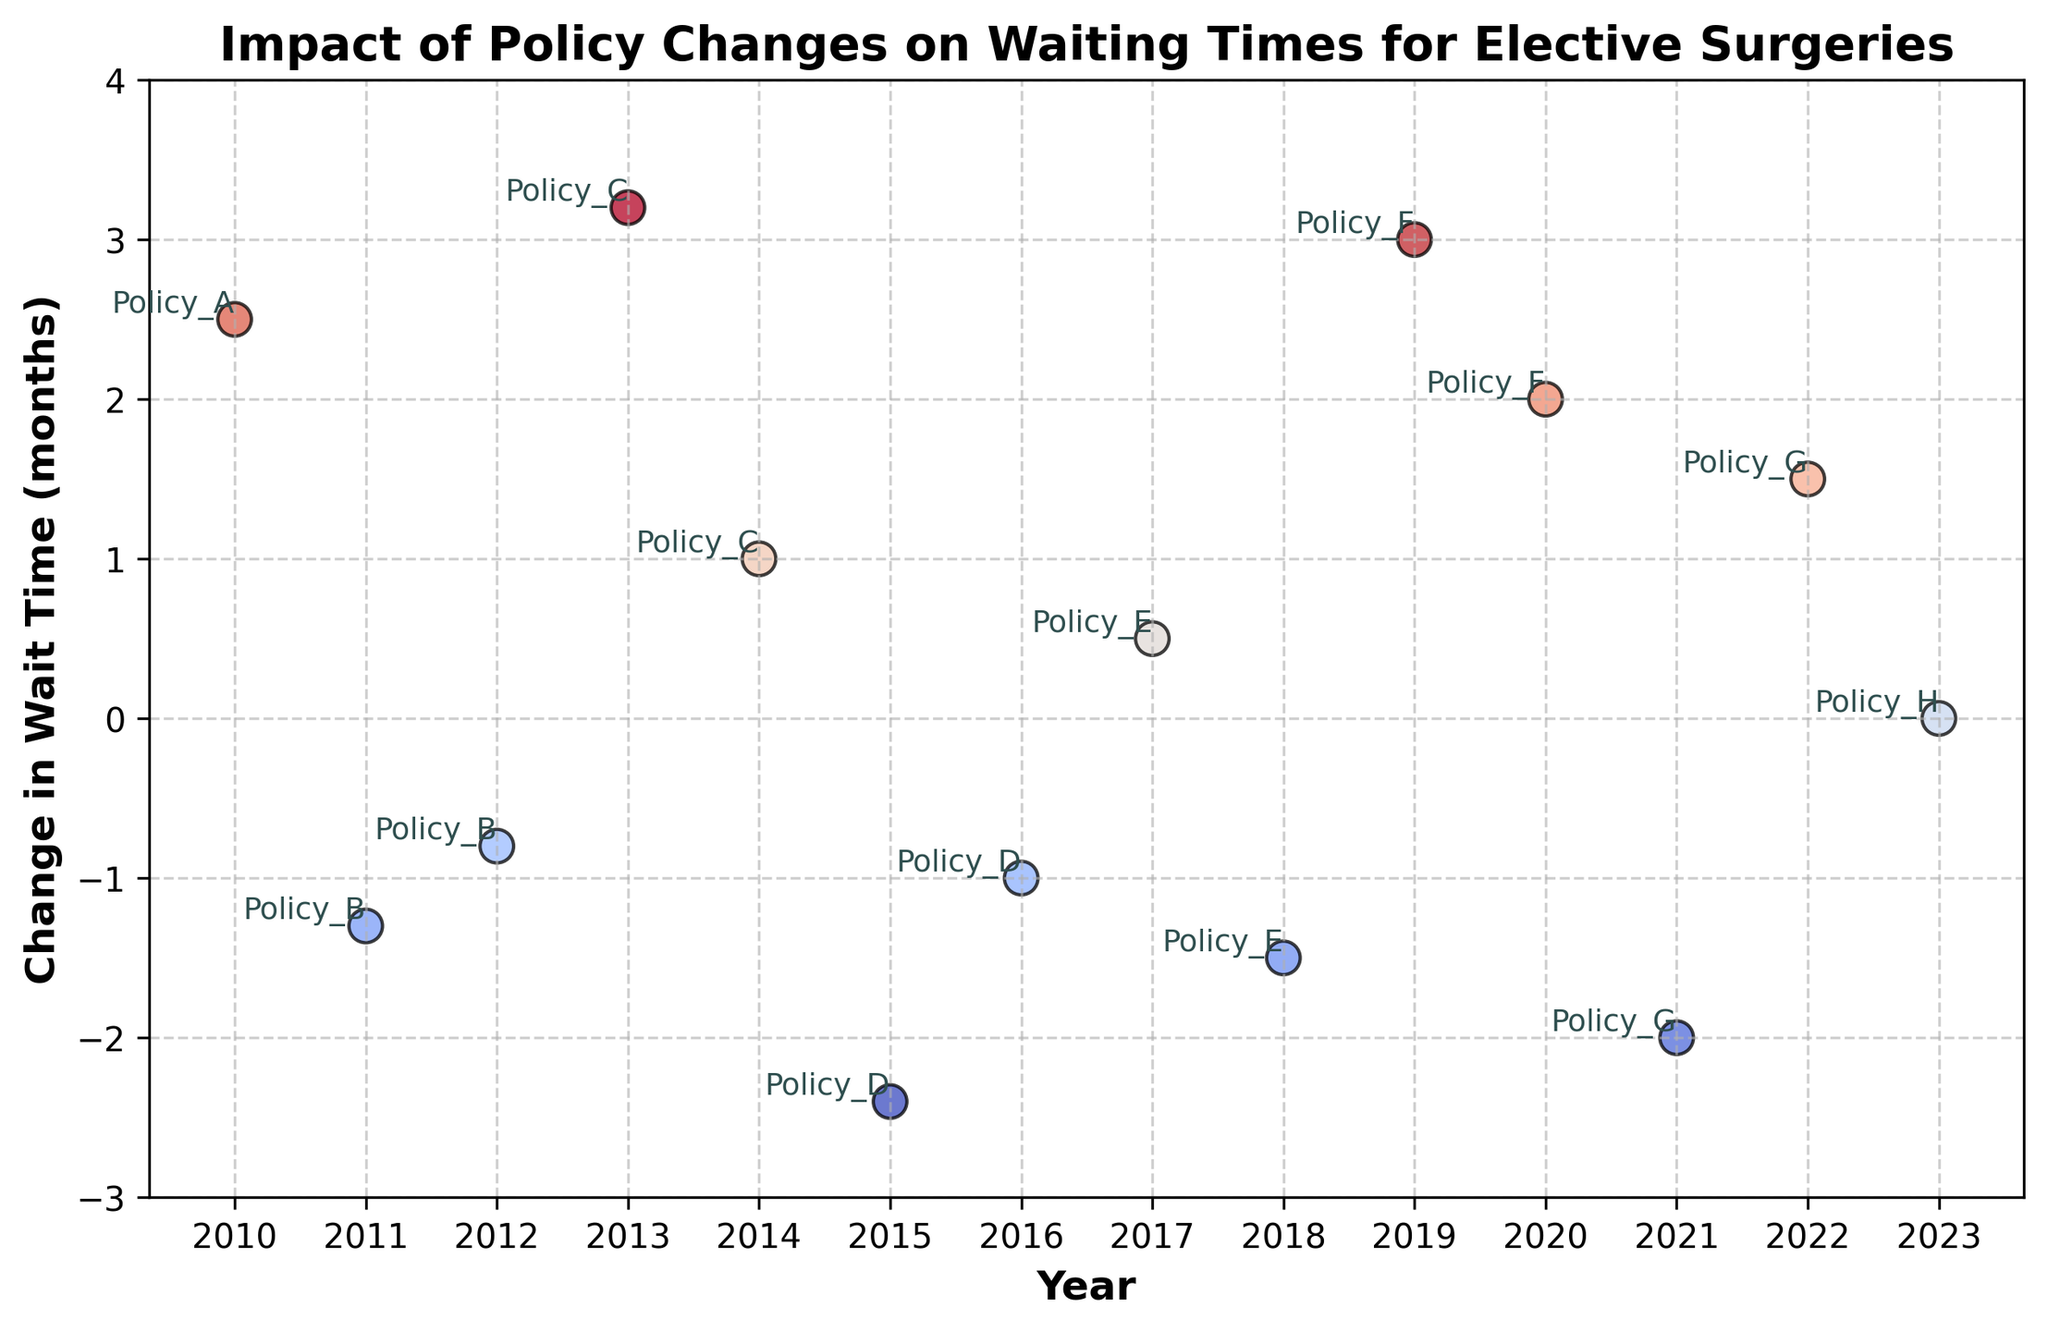How many policy changes resulted in a decrease in wait times? Identify points below 0 on the y-axis. Policies B, D, E, G resulted in a decrease
Answer: 4 Which year saw the greatest increase in waiting times? Find the highest positive value on the y-axis. 2013, with Policy C, had the highest increase with 3.2 months
Answer: 2013 What is the average change in wait time for policies that caused a decrease? Sum the decreases and divide by the number of those policies. (-1.3 + -0.8 + -2.4 + -1.0 + -1.5 + -2.0) / 6 = -9.0 / 6 = -1.5 months
Answer: -1.5 Which policies have both positive and negative impacts on waiting times? Identify the policies with points both above and below 0 on the y-axis. Policies E and G
Answer: E and G Are there more policies with a positive or negative impact on waiting times? Count the points above and below 0 on the y-axis. 8 are positive (A, C, C, D, E, F, F, G) and 6 are negative (B, B, D, E, G), so there are more positive
Answer: Positive Which policy change had the greatest variability in its impact on wait times? Look at the range of changes for each policy. Policy G varies from -2.0 to 1.5, a range of 3.5 months
Answer: G How many years had zero change in waiting times? Identify points on the y-axis at 0. Only 2023 with Policy H had zero change
Answer: 1 What is the sum of the maximum increase and the maximum decrease in wait times? Find the highest positive and lowest negative values. 3.2 (Policy C, 2013) + (-2.4) (Policy D, 2015) = 0.8
Answer: 0.8 What is the median change in wait times across all policies? List all changes, order them, and find the middle value. Changes: -2.4, -2.0, -1.5, -1.3, -1.0, -0.8, 0.0, 0.5, 1.0, 1.5, 2.0, 2.5, 3.0, 3.2. Middle values are between 0.0 and 0.5, so median is 0.25
Answer: 0.25 Which policy caused the highest reduction in waiting times and in which year? Identify the most negative point on the y-axis. Policy D in 2015 with -2.4 months
Answer: D in 2015 